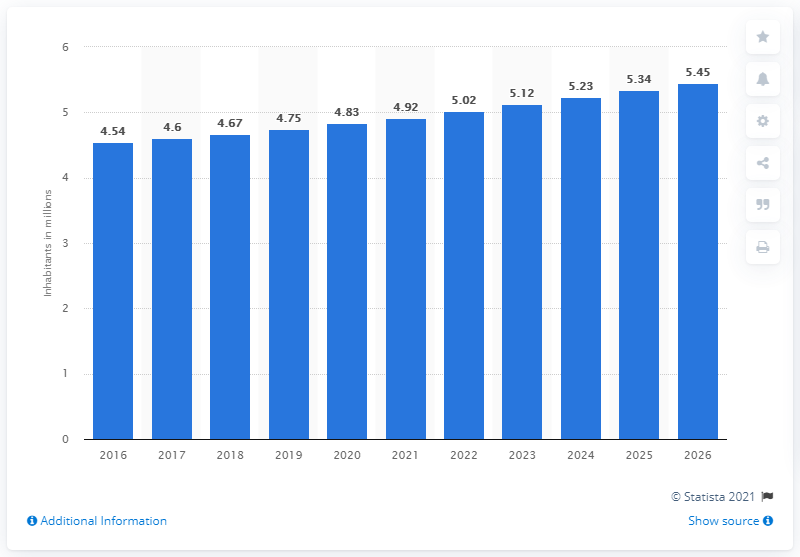Mention a couple of crucial points in this snapshot. In 2020, the population of the Central African Republic was 4.83... 